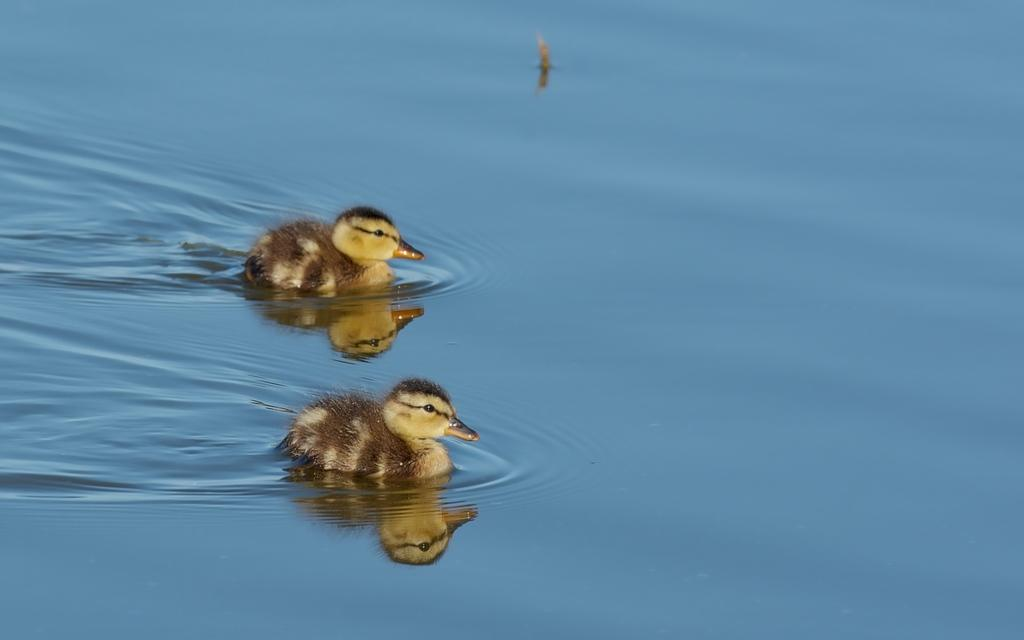What is the main subject of the image? The main subject of the image is birds. Where are the birds located in the image? The birds are in the center of the image. What is the birds' location in relation to the water? The birds are on the water. What type of rod can be seen in the hands of the boy in the image? There is no boy present in the image, and therefore no rod can be seen in his hands. 